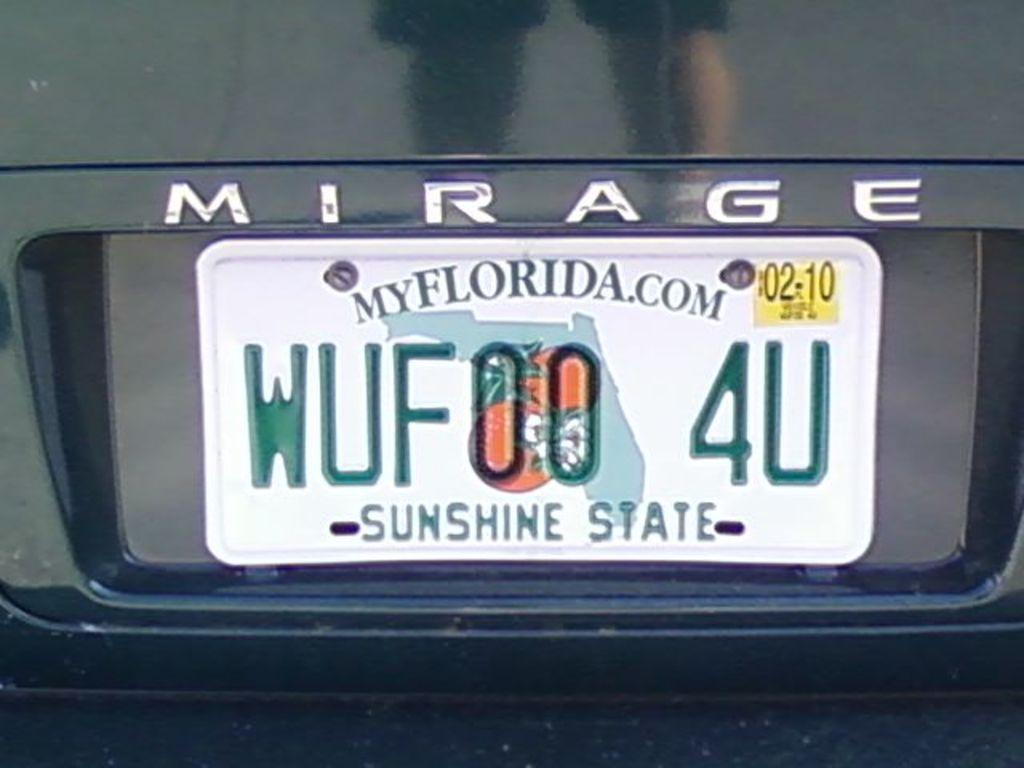<image>
Render a clear and concise summary of the photo. A Mirage car has a Florida license plate that reads WUF00 4U 